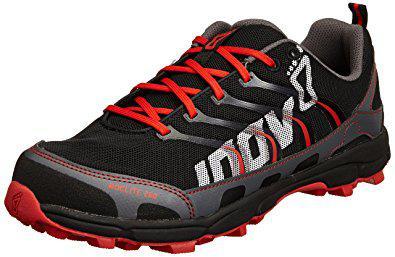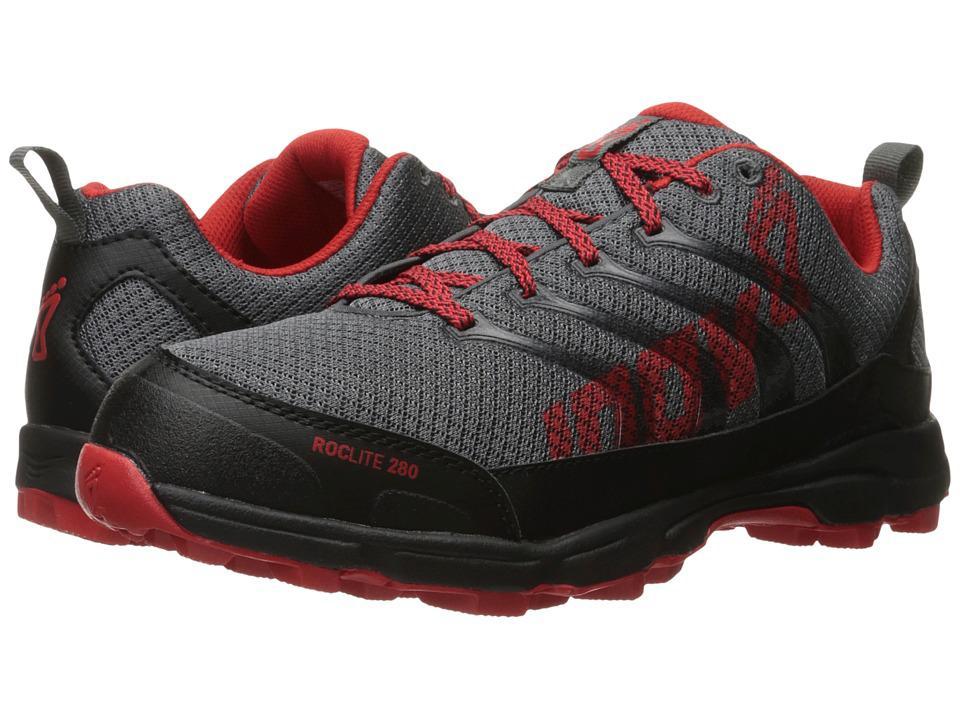The first image is the image on the left, the second image is the image on the right. Evaluate the accuracy of this statement regarding the images: "In one image, a pair of shoes has one shoe facing forward and one facing backward, the color of the shoe soles matching the inside fabric.". Is it true? Answer yes or no. Yes. The first image is the image on the left, the second image is the image on the right. Evaluate the accuracy of this statement regarding the images: "The left image contains one leftward angled sneaker, and the right image contains a pair of sneakers posed side-by-side heel-to-toe.". Is it true? Answer yes or no. Yes. 